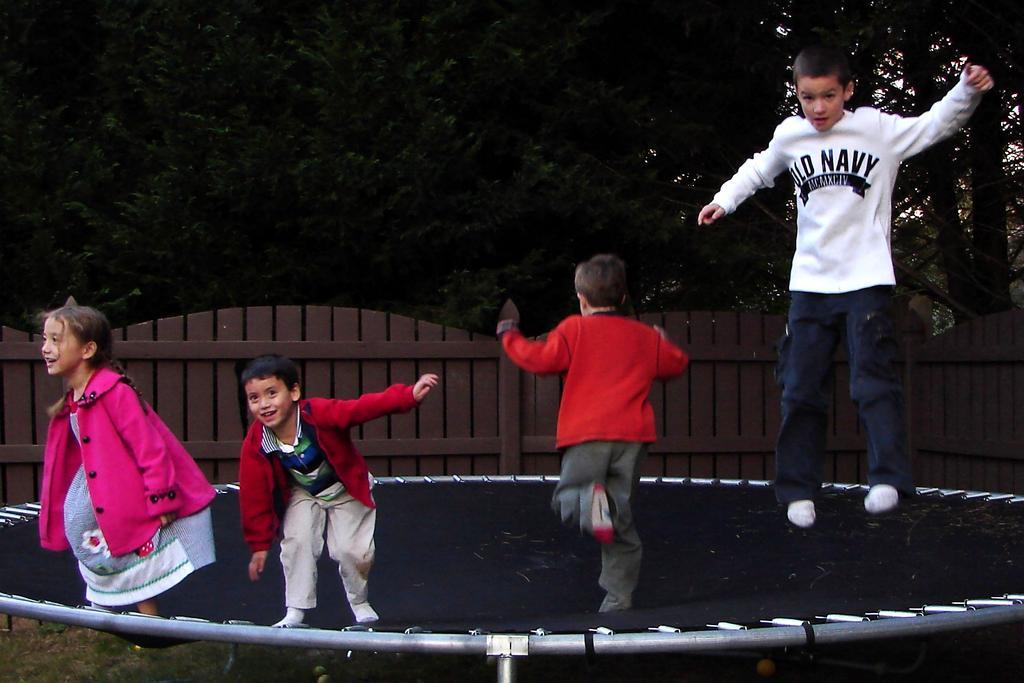How would you summarize this image in a sentence or two? In this image I can see few people on the black color trampoline. Back I can see trees and fencing. 